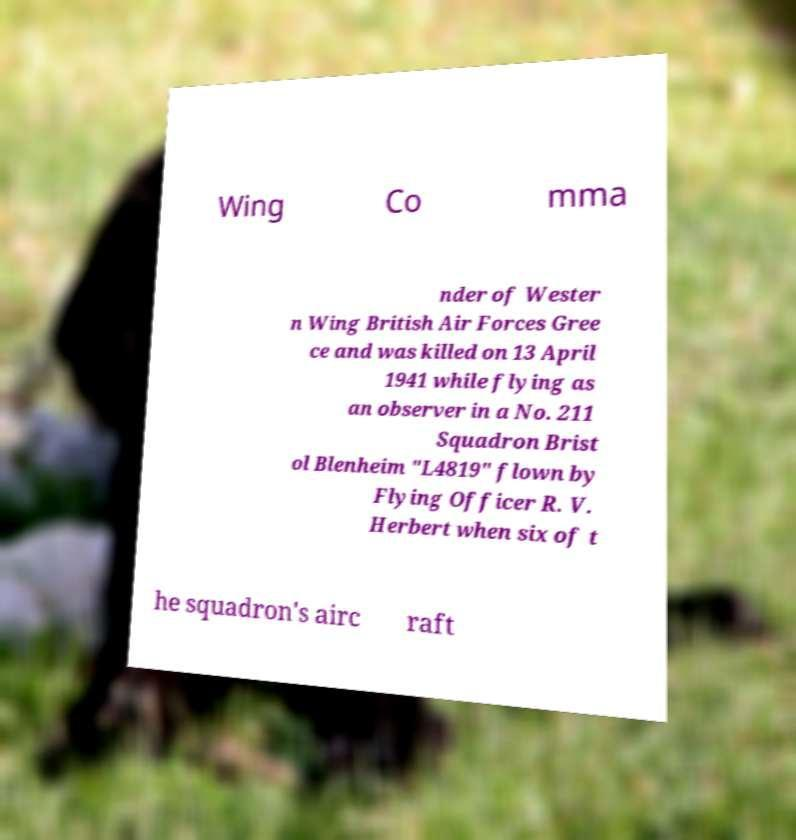Please read and relay the text visible in this image. What does it say? Wing Co mma nder of Wester n Wing British Air Forces Gree ce and was killed on 13 April 1941 while flying as an observer in a No. 211 Squadron Brist ol Blenheim "L4819" flown by Flying Officer R. V. Herbert when six of t he squadron's airc raft 